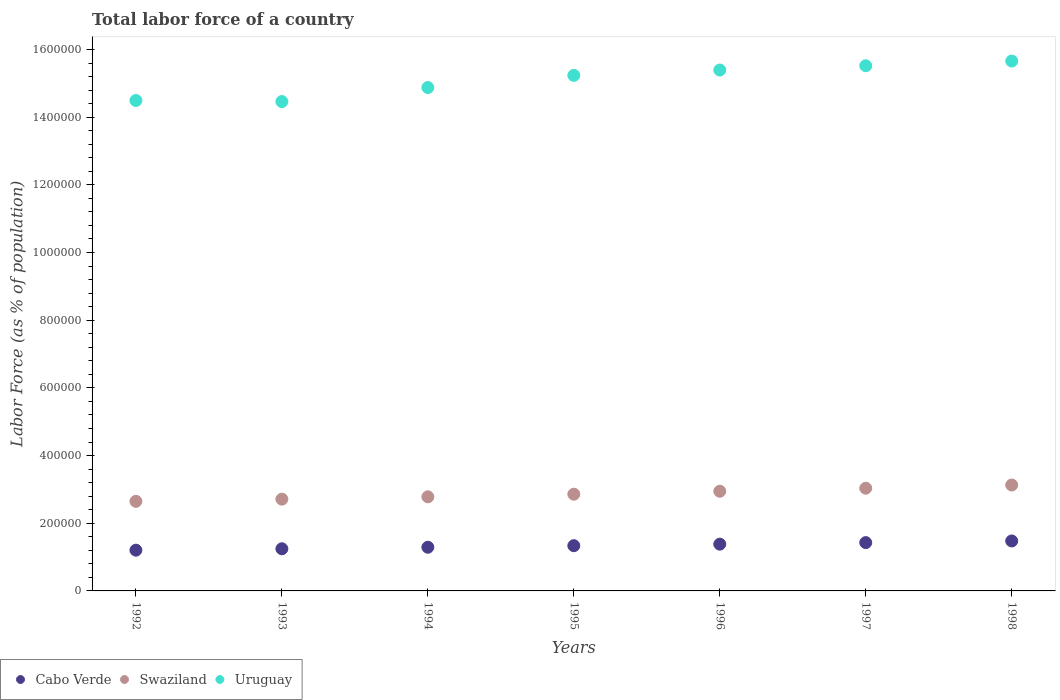How many different coloured dotlines are there?
Your answer should be very brief. 3. Is the number of dotlines equal to the number of legend labels?
Offer a very short reply. Yes. What is the percentage of labor force in Uruguay in 1997?
Ensure brevity in your answer.  1.55e+06. Across all years, what is the maximum percentage of labor force in Swaziland?
Your answer should be very brief. 3.13e+05. Across all years, what is the minimum percentage of labor force in Swaziland?
Provide a succinct answer. 2.65e+05. In which year was the percentage of labor force in Uruguay maximum?
Offer a very short reply. 1998. In which year was the percentage of labor force in Swaziland minimum?
Offer a terse response. 1992. What is the total percentage of labor force in Uruguay in the graph?
Ensure brevity in your answer.  1.06e+07. What is the difference between the percentage of labor force in Uruguay in 1994 and that in 1998?
Make the answer very short. -7.83e+04. What is the difference between the percentage of labor force in Swaziland in 1993 and the percentage of labor force in Cabo Verde in 1996?
Your response must be concise. 1.33e+05. What is the average percentage of labor force in Uruguay per year?
Provide a short and direct response. 1.51e+06. In the year 1993, what is the difference between the percentage of labor force in Cabo Verde and percentage of labor force in Swaziland?
Your response must be concise. -1.47e+05. What is the ratio of the percentage of labor force in Uruguay in 1997 to that in 1998?
Give a very brief answer. 0.99. What is the difference between the highest and the second highest percentage of labor force in Uruguay?
Make the answer very short. 1.39e+04. What is the difference between the highest and the lowest percentage of labor force in Uruguay?
Your answer should be very brief. 1.20e+05. In how many years, is the percentage of labor force in Uruguay greater than the average percentage of labor force in Uruguay taken over all years?
Your answer should be very brief. 4. Is the sum of the percentage of labor force in Cabo Verde in 1992 and 1996 greater than the maximum percentage of labor force in Uruguay across all years?
Your response must be concise. No. Is it the case that in every year, the sum of the percentage of labor force in Cabo Verde and percentage of labor force in Swaziland  is greater than the percentage of labor force in Uruguay?
Offer a terse response. No. How many dotlines are there?
Your answer should be compact. 3. What is the difference between two consecutive major ticks on the Y-axis?
Your answer should be very brief. 2.00e+05. Are the values on the major ticks of Y-axis written in scientific E-notation?
Keep it short and to the point. No. Does the graph contain grids?
Your answer should be compact. No. How many legend labels are there?
Offer a very short reply. 3. What is the title of the graph?
Ensure brevity in your answer.  Total labor force of a country. What is the label or title of the Y-axis?
Your response must be concise. Labor Force (as % of population). What is the Labor Force (as % of population) in Cabo Verde in 1992?
Offer a terse response. 1.20e+05. What is the Labor Force (as % of population) of Swaziland in 1992?
Make the answer very short. 2.65e+05. What is the Labor Force (as % of population) of Uruguay in 1992?
Give a very brief answer. 1.45e+06. What is the Labor Force (as % of population) in Cabo Verde in 1993?
Offer a terse response. 1.25e+05. What is the Labor Force (as % of population) of Swaziland in 1993?
Your answer should be compact. 2.71e+05. What is the Labor Force (as % of population) of Uruguay in 1993?
Provide a succinct answer. 1.45e+06. What is the Labor Force (as % of population) of Cabo Verde in 1994?
Your answer should be very brief. 1.29e+05. What is the Labor Force (as % of population) in Swaziland in 1994?
Keep it short and to the point. 2.78e+05. What is the Labor Force (as % of population) in Uruguay in 1994?
Your response must be concise. 1.49e+06. What is the Labor Force (as % of population) in Cabo Verde in 1995?
Provide a succinct answer. 1.34e+05. What is the Labor Force (as % of population) in Swaziland in 1995?
Make the answer very short. 2.86e+05. What is the Labor Force (as % of population) in Uruguay in 1995?
Make the answer very short. 1.52e+06. What is the Labor Force (as % of population) of Cabo Verde in 1996?
Offer a terse response. 1.38e+05. What is the Labor Force (as % of population) of Swaziland in 1996?
Provide a short and direct response. 2.95e+05. What is the Labor Force (as % of population) in Uruguay in 1996?
Provide a short and direct response. 1.54e+06. What is the Labor Force (as % of population) in Cabo Verde in 1997?
Ensure brevity in your answer.  1.43e+05. What is the Labor Force (as % of population) in Swaziland in 1997?
Provide a succinct answer. 3.04e+05. What is the Labor Force (as % of population) in Uruguay in 1997?
Your answer should be compact. 1.55e+06. What is the Labor Force (as % of population) of Cabo Verde in 1998?
Provide a short and direct response. 1.48e+05. What is the Labor Force (as % of population) of Swaziland in 1998?
Make the answer very short. 3.13e+05. What is the Labor Force (as % of population) of Uruguay in 1998?
Make the answer very short. 1.57e+06. Across all years, what is the maximum Labor Force (as % of population) of Cabo Verde?
Make the answer very short. 1.48e+05. Across all years, what is the maximum Labor Force (as % of population) in Swaziland?
Provide a succinct answer. 3.13e+05. Across all years, what is the maximum Labor Force (as % of population) of Uruguay?
Keep it short and to the point. 1.57e+06. Across all years, what is the minimum Labor Force (as % of population) in Cabo Verde?
Your answer should be very brief. 1.20e+05. Across all years, what is the minimum Labor Force (as % of population) in Swaziland?
Your answer should be compact. 2.65e+05. Across all years, what is the minimum Labor Force (as % of population) in Uruguay?
Your response must be concise. 1.45e+06. What is the total Labor Force (as % of population) of Cabo Verde in the graph?
Your answer should be very brief. 9.36e+05. What is the total Labor Force (as % of population) of Swaziland in the graph?
Provide a succinct answer. 2.01e+06. What is the total Labor Force (as % of population) in Uruguay in the graph?
Make the answer very short. 1.06e+07. What is the difference between the Labor Force (as % of population) in Cabo Verde in 1992 and that in 1993?
Make the answer very short. -4156. What is the difference between the Labor Force (as % of population) of Swaziland in 1992 and that in 1993?
Your response must be concise. -6428. What is the difference between the Labor Force (as % of population) of Uruguay in 1992 and that in 1993?
Provide a succinct answer. 3182. What is the difference between the Labor Force (as % of population) of Cabo Verde in 1992 and that in 1994?
Offer a very short reply. -8673. What is the difference between the Labor Force (as % of population) in Swaziland in 1992 and that in 1994?
Offer a very short reply. -1.33e+04. What is the difference between the Labor Force (as % of population) in Uruguay in 1992 and that in 1994?
Ensure brevity in your answer.  -3.83e+04. What is the difference between the Labor Force (as % of population) of Cabo Verde in 1992 and that in 1995?
Make the answer very short. -1.33e+04. What is the difference between the Labor Force (as % of population) in Swaziland in 1992 and that in 1995?
Offer a very short reply. -2.11e+04. What is the difference between the Labor Force (as % of population) in Uruguay in 1992 and that in 1995?
Your answer should be very brief. -7.42e+04. What is the difference between the Labor Force (as % of population) in Cabo Verde in 1992 and that in 1996?
Provide a succinct answer. -1.78e+04. What is the difference between the Labor Force (as % of population) in Swaziland in 1992 and that in 1996?
Your response must be concise. -2.98e+04. What is the difference between the Labor Force (as % of population) in Uruguay in 1992 and that in 1996?
Offer a very short reply. -9.00e+04. What is the difference between the Labor Force (as % of population) in Cabo Verde in 1992 and that in 1997?
Make the answer very short. -2.23e+04. What is the difference between the Labor Force (as % of population) of Swaziland in 1992 and that in 1997?
Keep it short and to the point. -3.87e+04. What is the difference between the Labor Force (as % of population) in Uruguay in 1992 and that in 1997?
Your response must be concise. -1.03e+05. What is the difference between the Labor Force (as % of population) in Cabo Verde in 1992 and that in 1998?
Your response must be concise. -2.72e+04. What is the difference between the Labor Force (as % of population) in Swaziland in 1992 and that in 1998?
Your response must be concise. -4.81e+04. What is the difference between the Labor Force (as % of population) in Uruguay in 1992 and that in 1998?
Your answer should be compact. -1.17e+05. What is the difference between the Labor Force (as % of population) of Cabo Verde in 1993 and that in 1994?
Offer a very short reply. -4517. What is the difference between the Labor Force (as % of population) of Swaziland in 1993 and that in 1994?
Provide a succinct answer. -6888. What is the difference between the Labor Force (as % of population) in Uruguay in 1993 and that in 1994?
Make the answer very short. -4.15e+04. What is the difference between the Labor Force (as % of population) of Cabo Verde in 1993 and that in 1995?
Provide a short and direct response. -9101. What is the difference between the Labor Force (as % of population) in Swaziland in 1993 and that in 1995?
Your answer should be compact. -1.46e+04. What is the difference between the Labor Force (as % of population) of Uruguay in 1993 and that in 1995?
Your answer should be very brief. -7.74e+04. What is the difference between the Labor Force (as % of population) of Cabo Verde in 1993 and that in 1996?
Ensure brevity in your answer.  -1.37e+04. What is the difference between the Labor Force (as % of population) of Swaziland in 1993 and that in 1996?
Your answer should be very brief. -2.33e+04. What is the difference between the Labor Force (as % of population) in Uruguay in 1993 and that in 1996?
Make the answer very short. -9.32e+04. What is the difference between the Labor Force (as % of population) in Cabo Verde in 1993 and that in 1997?
Keep it short and to the point. -1.82e+04. What is the difference between the Labor Force (as % of population) in Swaziland in 1993 and that in 1997?
Give a very brief answer. -3.23e+04. What is the difference between the Labor Force (as % of population) of Uruguay in 1993 and that in 1997?
Keep it short and to the point. -1.06e+05. What is the difference between the Labor Force (as % of population) in Cabo Verde in 1993 and that in 1998?
Your answer should be very brief. -2.31e+04. What is the difference between the Labor Force (as % of population) of Swaziland in 1993 and that in 1998?
Make the answer very short. -4.17e+04. What is the difference between the Labor Force (as % of population) in Uruguay in 1993 and that in 1998?
Give a very brief answer. -1.20e+05. What is the difference between the Labor Force (as % of population) of Cabo Verde in 1994 and that in 1995?
Provide a succinct answer. -4584. What is the difference between the Labor Force (as % of population) of Swaziland in 1994 and that in 1995?
Offer a very short reply. -7754. What is the difference between the Labor Force (as % of population) in Uruguay in 1994 and that in 1995?
Your answer should be very brief. -3.59e+04. What is the difference between the Labor Force (as % of population) of Cabo Verde in 1994 and that in 1996?
Your answer should be compact. -9141. What is the difference between the Labor Force (as % of population) in Swaziland in 1994 and that in 1996?
Keep it short and to the point. -1.64e+04. What is the difference between the Labor Force (as % of population) in Uruguay in 1994 and that in 1996?
Your response must be concise. -5.17e+04. What is the difference between the Labor Force (as % of population) in Cabo Verde in 1994 and that in 1997?
Your answer should be compact. -1.36e+04. What is the difference between the Labor Force (as % of population) of Swaziland in 1994 and that in 1997?
Keep it short and to the point. -2.54e+04. What is the difference between the Labor Force (as % of population) of Uruguay in 1994 and that in 1997?
Your answer should be compact. -6.44e+04. What is the difference between the Labor Force (as % of population) of Cabo Verde in 1994 and that in 1998?
Ensure brevity in your answer.  -1.86e+04. What is the difference between the Labor Force (as % of population) in Swaziland in 1994 and that in 1998?
Keep it short and to the point. -3.48e+04. What is the difference between the Labor Force (as % of population) of Uruguay in 1994 and that in 1998?
Keep it short and to the point. -7.83e+04. What is the difference between the Labor Force (as % of population) of Cabo Verde in 1995 and that in 1996?
Ensure brevity in your answer.  -4557. What is the difference between the Labor Force (as % of population) of Swaziland in 1995 and that in 1996?
Offer a terse response. -8696. What is the difference between the Labor Force (as % of population) in Uruguay in 1995 and that in 1996?
Give a very brief answer. -1.58e+04. What is the difference between the Labor Force (as % of population) in Cabo Verde in 1995 and that in 1997?
Your answer should be compact. -9062. What is the difference between the Labor Force (as % of population) of Swaziland in 1995 and that in 1997?
Offer a terse response. -1.77e+04. What is the difference between the Labor Force (as % of population) of Uruguay in 1995 and that in 1997?
Keep it short and to the point. -2.85e+04. What is the difference between the Labor Force (as % of population) in Cabo Verde in 1995 and that in 1998?
Provide a succinct answer. -1.40e+04. What is the difference between the Labor Force (as % of population) of Swaziland in 1995 and that in 1998?
Your answer should be compact. -2.71e+04. What is the difference between the Labor Force (as % of population) in Uruguay in 1995 and that in 1998?
Keep it short and to the point. -4.24e+04. What is the difference between the Labor Force (as % of population) of Cabo Verde in 1996 and that in 1997?
Provide a succinct answer. -4505. What is the difference between the Labor Force (as % of population) in Swaziland in 1996 and that in 1997?
Provide a succinct answer. -8958. What is the difference between the Labor Force (as % of population) of Uruguay in 1996 and that in 1997?
Offer a very short reply. -1.27e+04. What is the difference between the Labor Force (as % of population) of Cabo Verde in 1996 and that in 1998?
Your answer should be compact. -9420. What is the difference between the Labor Force (as % of population) in Swaziland in 1996 and that in 1998?
Ensure brevity in your answer.  -1.84e+04. What is the difference between the Labor Force (as % of population) of Uruguay in 1996 and that in 1998?
Your answer should be compact. -2.66e+04. What is the difference between the Labor Force (as % of population) in Cabo Verde in 1997 and that in 1998?
Keep it short and to the point. -4915. What is the difference between the Labor Force (as % of population) in Swaziland in 1997 and that in 1998?
Your answer should be very brief. -9414. What is the difference between the Labor Force (as % of population) in Uruguay in 1997 and that in 1998?
Provide a succinct answer. -1.39e+04. What is the difference between the Labor Force (as % of population) in Cabo Verde in 1992 and the Labor Force (as % of population) in Swaziland in 1993?
Offer a very short reply. -1.51e+05. What is the difference between the Labor Force (as % of population) of Cabo Verde in 1992 and the Labor Force (as % of population) of Uruguay in 1993?
Your answer should be compact. -1.33e+06. What is the difference between the Labor Force (as % of population) in Swaziland in 1992 and the Labor Force (as % of population) in Uruguay in 1993?
Your answer should be compact. -1.18e+06. What is the difference between the Labor Force (as % of population) of Cabo Verde in 1992 and the Labor Force (as % of population) of Swaziland in 1994?
Provide a succinct answer. -1.58e+05. What is the difference between the Labor Force (as % of population) of Cabo Verde in 1992 and the Labor Force (as % of population) of Uruguay in 1994?
Make the answer very short. -1.37e+06. What is the difference between the Labor Force (as % of population) in Swaziland in 1992 and the Labor Force (as % of population) in Uruguay in 1994?
Offer a very short reply. -1.22e+06. What is the difference between the Labor Force (as % of population) in Cabo Verde in 1992 and the Labor Force (as % of population) in Swaziland in 1995?
Keep it short and to the point. -1.65e+05. What is the difference between the Labor Force (as % of population) in Cabo Verde in 1992 and the Labor Force (as % of population) in Uruguay in 1995?
Ensure brevity in your answer.  -1.40e+06. What is the difference between the Labor Force (as % of population) of Swaziland in 1992 and the Labor Force (as % of population) of Uruguay in 1995?
Provide a short and direct response. -1.26e+06. What is the difference between the Labor Force (as % of population) of Cabo Verde in 1992 and the Labor Force (as % of population) of Swaziland in 1996?
Make the answer very short. -1.74e+05. What is the difference between the Labor Force (as % of population) of Cabo Verde in 1992 and the Labor Force (as % of population) of Uruguay in 1996?
Offer a terse response. -1.42e+06. What is the difference between the Labor Force (as % of population) of Swaziland in 1992 and the Labor Force (as % of population) of Uruguay in 1996?
Provide a succinct answer. -1.27e+06. What is the difference between the Labor Force (as % of population) in Cabo Verde in 1992 and the Labor Force (as % of population) in Swaziland in 1997?
Offer a terse response. -1.83e+05. What is the difference between the Labor Force (as % of population) in Cabo Verde in 1992 and the Labor Force (as % of population) in Uruguay in 1997?
Give a very brief answer. -1.43e+06. What is the difference between the Labor Force (as % of population) of Swaziland in 1992 and the Labor Force (as % of population) of Uruguay in 1997?
Provide a short and direct response. -1.29e+06. What is the difference between the Labor Force (as % of population) of Cabo Verde in 1992 and the Labor Force (as % of population) of Swaziland in 1998?
Your answer should be very brief. -1.93e+05. What is the difference between the Labor Force (as % of population) of Cabo Verde in 1992 and the Labor Force (as % of population) of Uruguay in 1998?
Provide a short and direct response. -1.45e+06. What is the difference between the Labor Force (as % of population) of Swaziland in 1992 and the Labor Force (as % of population) of Uruguay in 1998?
Provide a succinct answer. -1.30e+06. What is the difference between the Labor Force (as % of population) of Cabo Verde in 1993 and the Labor Force (as % of population) of Swaziland in 1994?
Offer a very short reply. -1.54e+05. What is the difference between the Labor Force (as % of population) in Cabo Verde in 1993 and the Labor Force (as % of population) in Uruguay in 1994?
Make the answer very short. -1.36e+06. What is the difference between the Labor Force (as % of population) in Swaziland in 1993 and the Labor Force (as % of population) in Uruguay in 1994?
Offer a very short reply. -1.22e+06. What is the difference between the Labor Force (as % of population) of Cabo Verde in 1993 and the Labor Force (as % of population) of Swaziland in 1995?
Your response must be concise. -1.61e+05. What is the difference between the Labor Force (as % of population) in Cabo Verde in 1993 and the Labor Force (as % of population) in Uruguay in 1995?
Your response must be concise. -1.40e+06. What is the difference between the Labor Force (as % of population) of Swaziland in 1993 and the Labor Force (as % of population) of Uruguay in 1995?
Ensure brevity in your answer.  -1.25e+06. What is the difference between the Labor Force (as % of population) in Cabo Verde in 1993 and the Labor Force (as % of population) in Swaziland in 1996?
Provide a short and direct response. -1.70e+05. What is the difference between the Labor Force (as % of population) of Cabo Verde in 1993 and the Labor Force (as % of population) of Uruguay in 1996?
Your response must be concise. -1.41e+06. What is the difference between the Labor Force (as % of population) of Swaziland in 1993 and the Labor Force (as % of population) of Uruguay in 1996?
Your answer should be very brief. -1.27e+06. What is the difference between the Labor Force (as % of population) of Cabo Verde in 1993 and the Labor Force (as % of population) of Swaziland in 1997?
Offer a terse response. -1.79e+05. What is the difference between the Labor Force (as % of population) in Cabo Verde in 1993 and the Labor Force (as % of population) in Uruguay in 1997?
Give a very brief answer. -1.43e+06. What is the difference between the Labor Force (as % of population) in Swaziland in 1993 and the Labor Force (as % of population) in Uruguay in 1997?
Your response must be concise. -1.28e+06. What is the difference between the Labor Force (as % of population) in Cabo Verde in 1993 and the Labor Force (as % of population) in Swaziland in 1998?
Keep it short and to the point. -1.88e+05. What is the difference between the Labor Force (as % of population) in Cabo Verde in 1993 and the Labor Force (as % of population) in Uruguay in 1998?
Ensure brevity in your answer.  -1.44e+06. What is the difference between the Labor Force (as % of population) of Swaziland in 1993 and the Labor Force (as % of population) of Uruguay in 1998?
Provide a short and direct response. -1.29e+06. What is the difference between the Labor Force (as % of population) of Cabo Verde in 1994 and the Labor Force (as % of population) of Swaziland in 1995?
Your answer should be compact. -1.57e+05. What is the difference between the Labor Force (as % of population) in Cabo Verde in 1994 and the Labor Force (as % of population) in Uruguay in 1995?
Offer a terse response. -1.39e+06. What is the difference between the Labor Force (as % of population) of Swaziland in 1994 and the Labor Force (as % of population) of Uruguay in 1995?
Make the answer very short. -1.25e+06. What is the difference between the Labor Force (as % of population) in Cabo Verde in 1994 and the Labor Force (as % of population) in Swaziland in 1996?
Offer a very short reply. -1.65e+05. What is the difference between the Labor Force (as % of population) of Cabo Verde in 1994 and the Labor Force (as % of population) of Uruguay in 1996?
Give a very brief answer. -1.41e+06. What is the difference between the Labor Force (as % of population) in Swaziland in 1994 and the Labor Force (as % of population) in Uruguay in 1996?
Give a very brief answer. -1.26e+06. What is the difference between the Labor Force (as % of population) in Cabo Verde in 1994 and the Labor Force (as % of population) in Swaziland in 1997?
Offer a terse response. -1.74e+05. What is the difference between the Labor Force (as % of population) of Cabo Verde in 1994 and the Labor Force (as % of population) of Uruguay in 1997?
Make the answer very short. -1.42e+06. What is the difference between the Labor Force (as % of population) in Swaziland in 1994 and the Labor Force (as % of population) in Uruguay in 1997?
Offer a very short reply. -1.27e+06. What is the difference between the Labor Force (as % of population) in Cabo Verde in 1994 and the Labor Force (as % of population) in Swaziland in 1998?
Offer a very short reply. -1.84e+05. What is the difference between the Labor Force (as % of population) of Cabo Verde in 1994 and the Labor Force (as % of population) of Uruguay in 1998?
Ensure brevity in your answer.  -1.44e+06. What is the difference between the Labor Force (as % of population) of Swaziland in 1994 and the Labor Force (as % of population) of Uruguay in 1998?
Provide a succinct answer. -1.29e+06. What is the difference between the Labor Force (as % of population) of Cabo Verde in 1995 and the Labor Force (as % of population) of Swaziland in 1996?
Ensure brevity in your answer.  -1.61e+05. What is the difference between the Labor Force (as % of population) in Cabo Verde in 1995 and the Labor Force (as % of population) in Uruguay in 1996?
Your answer should be compact. -1.41e+06. What is the difference between the Labor Force (as % of population) in Swaziland in 1995 and the Labor Force (as % of population) in Uruguay in 1996?
Give a very brief answer. -1.25e+06. What is the difference between the Labor Force (as % of population) in Cabo Verde in 1995 and the Labor Force (as % of population) in Swaziland in 1997?
Offer a terse response. -1.70e+05. What is the difference between the Labor Force (as % of population) of Cabo Verde in 1995 and the Labor Force (as % of population) of Uruguay in 1997?
Provide a succinct answer. -1.42e+06. What is the difference between the Labor Force (as % of population) of Swaziland in 1995 and the Labor Force (as % of population) of Uruguay in 1997?
Give a very brief answer. -1.27e+06. What is the difference between the Labor Force (as % of population) of Cabo Verde in 1995 and the Labor Force (as % of population) of Swaziland in 1998?
Ensure brevity in your answer.  -1.79e+05. What is the difference between the Labor Force (as % of population) in Cabo Verde in 1995 and the Labor Force (as % of population) in Uruguay in 1998?
Provide a short and direct response. -1.43e+06. What is the difference between the Labor Force (as % of population) in Swaziland in 1995 and the Labor Force (as % of population) in Uruguay in 1998?
Offer a very short reply. -1.28e+06. What is the difference between the Labor Force (as % of population) of Cabo Verde in 1996 and the Labor Force (as % of population) of Swaziland in 1997?
Offer a terse response. -1.65e+05. What is the difference between the Labor Force (as % of population) of Cabo Verde in 1996 and the Labor Force (as % of population) of Uruguay in 1997?
Ensure brevity in your answer.  -1.41e+06. What is the difference between the Labor Force (as % of population) of Swaziland in 1996 and the Labor Force (as % of population) of Uruguay in 1997?
Your answer should be very brief. -1.26e+06. What is the difference between the Labor Force (as % of population) of Cabo Verde in 1996 and the Labor Force (as % of population) of Swaziland in 1998?
Your answer should be compact. -1.75e+05. What is the difference between the Labor Force (as % of population) of Cabo Verde in 1996 and the Labor Force (as % of population) of Uruguay in 1998?
Keep it short and to the point. -1.43e+06. What is the difference between the Labor Force (as % of population) of Swaziland in 1996 and the Labor Force (as % of population) of Uruguay in 1998?
Provide a short and direct response. -1.27e+06. What is the difference between the Labor Force (as % of population) in Cabo Verde in 1997 and the Labor Force (as % of population) in Swaziland in 1998?
Give a very brief answer. -1.70e+05. What is the difference between the Labor Force (as % of population) in Cabo Verde in 1997 and the Labor Force (as % of population) in Uruguay in 1998?
Your answer should be very brief. -1.42e+06. What is the difference between the Labor Force (as % of population) of Swaziland in 1997 and the Labor Force (as % of population) of Uruguay in 1998?
Provide a succinct answer. -1.26e+06. What is the average Labor Force (as % of population) in Cabo Verde per year?
Offer a very short reply. 1.34e+05. What is the average Labor Force (as % of population) of Swaziland per year?
Offer a very short reply. 2.87e+05. What is the average Labor Force (as % of population) in Uruguay per year?
Your response must be concise. 1.51e+06. In the year 1992, what is the difference between the Labor Force (as % of population) of Cabo Verde and Labor Force (as % of population) of Swaziland?
Make the answer very short. -1.44e+05. In the year 1992, what is the difference between the Labor Force (as % of population) in Cabo Verde and Labor Force (as % of population) in Uruguay?
Make the answer very short. -1.33e+06. In the year 1992, what is the difference between the Labor Force (as % of population) of Swaziland and Labor Force (as % of population) of Uruguay?
Make the answer very short. -1.18e+06. In the year 1993, what is the difference between the Labor Force (as % of population) of Cabo Verde and Labor Force (as % of population) of Swaziland?
Offer a very short reply. -1.47e+05. In the year 1993, what is the difference between the Labor Force (as % of population) in Cabo Verde and Labor Force (as % of population) in Uruguay?
Keep it short and to the point. -1.32e+06. In the year 1993, what is the difference between the Labor Force (as % of population) of Swaziland and Labor Force (as % of population) of Uruguay?
Give a very brief answer. -1.17e+06. In the year 1994, what is the difference between the Labor Force (as % of population) of Cabo Verde and Labor Force (as % of population) of Swaziland?
Make the answer very short. -1.49e+05. In the year 1994, what is the difference between the Labor Force (as % of population) in Cabo Verde and Labor Force (as % of population) in Uruguay?
Your answer should be very brief. -1.36e+06. In the year 1994, what is the difference between the Labor Force (as % of population) of Swaziland and Labor Force (as % of population) of Uruguay?
Your answer should be very brief. -1.21e+06. In the year 1995, what is the difference between the Labor Force (as % of population) in Cabo Verde and Labor Force (as % of population) in Swaziland?
Keep it short and to the point. -1.52e+05. In the year 1995, what is the difference between the Labor Force (as % of population) of Cabo Verde and Labor Force (as % of population) of Uruguay?
Keep it short and to the point. -1.39e+06. In the year 1995, what is the difference between the Labor Force (as % of population) of Swaziland and Labor Force (as % of population) of Uruguay?
Provide a succinct answer. -1.24e+06. In the year 1996, what is the difference between the Labor Force (as % of population) of Cabo Verde and Labor Force (as % of population) of Swaziland?
Your answer should be compact. -1.56e+05. In the year 1996, what is the difference between the Labor Force (as % of population) in Cabo Verde and Labor Force (as % of population) in Uruguay?
Your response must be concise. -1.40e+06. In the year 1996, what is the difference between the Labor Force (as % of population) in Swaziland and Labor Force (as % of population) in Uruguay?
Provide a succinct answer. -1.24e+06. In the year 1997, what is the difference between the Labor Force (as % of population) in Cabo Verde and Labor Force (as % of population) in Swaziland?
Keep it short and to the point. -1.61e+05. In the year 1997, what is the difference between the Labor Force (as % of population) of Cabo Verde and Labor Force (as % of population) of Uruguay?
Make the answer very short. -1.41e+06. In the year 1997, what is the difference between the Labor Force (as % of population) in Swaziland and Labor Force (as % of population) in Uruguay?
Make the answer very short. -1.25e+06. In the year 1998, what is the difference between the Labor Force (as % of population) of Cabo Verde and Labor Force (as % of population) of Swaziland?
Make the answer very short. -1.65e+05. In the year 1998, what is the difference between the Labor Force (as % of population) in Cabo Verde and Labor Force (as % of population) in Uruguay?
Ensure brevity in your answer.  -1.42e+06. In the year 1998, what is the difference between the Labor Force (as % of population) of Swaziland and Labor Force (as % of population) of Uruguay?
Your response must be concise. -1.25e+06. What is the ratio of the Labor Force (as % of population) of Cabo Verde in 1992 to that in 1993?
Offer a very short reply. 0.97. What is the ratio of the Labor Force (as % of population) of Swaziland in 1992 to that in 1993?
Give a very brief answer. 0.98. What is the ratio of the Labor Force (as % of population) of Cabo Verde in 1992 to that in 1994?
Provide a short and direct response. 0.93. What is the ratio of the Labor Force (as % of population) in Swaziland in 1992 to that in 1994?
Make the answer very short. 0.95. What is the ratio of the Labor Force (as % of population) of Uruguay in 1992 to that in 1994?
Provide a short and direct response. 0.97. What is the ratio of the Labor Force (as % of population) of Cabo Verde in 1992 to that in 1995?
Give a very brief answer. 0.9. What is the ratio of the Labor Force (as % of population) of Swaziland in 1992 to that in 1995?
Provide a succinct answer. 0.93. What is the ratio of the Labor Force (as % of population) of Uruguay in 1992 to that in 1995?
Offer a very short reply. 0.95. What is the ratio of the Labor Force (as % of population) of Cabo Verde in 1992 to that in 1996?
Provide a succinct answer. 0.87. What is the ratio of the Labor Force (as % of population) of Swaziland in 1992 to that in 1996?
Give a very brief answer. 0.9. What is the ratio of the Labor Force (as % of population) in Uruguay in 1992 to that in 1996?
Provide a succinct answer. 0.94. What is the ratio of the Labor Force (as % of population) in Cabo Verde in 1992 to that in 1997?
Provide a short and direct response. 0.84. What is the ratio of the Labor Force (as % of population) of Swaziland in 1992 to that in 1997?
Give a very brief answer. 0.87. What is the ratio of the Labor Force (as % of population) in Uruguay in 1992 to that in 1997?
Your answer should be very brief. 0.93. What is the ratio of the Labor Force (as % of population) in Cabo Verde in 1992 to that in 1998?
Make the answer very short. 0.82. What is the ratio of the Labor Force (as % of population) in Swaziland in 1992 to that in 1998?
Provide a short and direct response. 0.85. What is the ratio of the Labor Force (as % of population) of Uruguay in 1992 to that in 1998?
Make the answer very short. 0.93. What is the ratio of the Labor Force (as % of population) of Cabo Verde in 1993 to that in 1994?
Offer a very short reply. 0.96. What is the ratio of the Labor Force (as % of population) in Swaziland in 1993 to that in 1994?
Offer a very short reply. 0.98. What is the ratio of the Labor Force (as % of population) in Uruguay in 1993 to that in 1994?
Offer a very short reply. 0.97. What is the ratio of the Labor Force (as % of population) in Cabo Verde in 1993 to that in 1995?
Provide a succinct answer. 0.93. What is the ratio of the Labor Force (as % of population) in Swaziland in 1993 to that in 1995?
Give a very brief answer. 0.95. What is the ratio of the Labor Force (as % of population) in Uruguay in 1993 to that in 1995?
Offer a very short reply. 0.95. What is the ratio of the Labor Force (as % of population) in Cabo Verde in 1993 to that in 1996?
Keep it short and to the point. 0.9. What is the ratio of the Labor Force (as % of population) in Swaziland in 1993 to that in 1996?
Offer a very short reply. 0.92. What is the ratio of the Labor Force (as % of population) in Uruguay in 1993 to that in 1996?
Your response must be concise. 0.94. What is the ratio of the Labor Force (as % of population) in Cabo Verde in 1993 to that in 1997?
Your answer should be compact. 0.87. What is the ratio of the Labor Force (as % of population) in Swaziland in 1993 to that in 1997?
Your answer should be compact. 0.89. What is the ratio of the Labor Force (as % of population) in Uruguay in 1993 to that in 1997?
Your response must be concise. 0.93. What is the ratio of the Labor Force (as % of population) of Cabo Verde in 1993 to that in 1998?
Provide a succinct answer. 0.84. What is the ratio of the Labor Force (as % of population) in Swaziland in 1993 to that in 1998?
Offer a very short reply. 0.87. What is the ratio of the Labor Force (as % of population) of Uruguay in 1993 to that in 1998?
Keep it short and to the point. 0.92. What is the ratio of the Labor Force (as % of population) of Cabo Verde in 1994 to that in 1995?
Give a very brief answer. 0.97. What is the ratio of the Labor Force (as % of population) of Swaziland in 1994 to that in 1995?
Your answer should be very brief. 0.97. What is the ratio of the Labor Force (as % of population) in Uruguay in 1994 to that in 1995?
Keep it short and to the point. 0.98. What is the ratio of the Labor Force (as % of population) of Cabo Verde in 1994 to that in 1996?
Keep it short and to the point. 0.93. What is the ratio of the Labor Force (as % of population) of Swaziland in 1994 to that in 1996?
Provide a short and direct response. 0.94. What is the ratio of the Labor Force (as % of population) in Uruguay in 1994 to that in 1996?
Provide a succinct answer. 0.97. What is the ratio of the Labor Force (as % of population) of Cabo Verde in 1994 to that in 1997?
Your response must be concise. 0.9. What is the ratio of the Labor Force (as % of population) in Swaziland in 1994 to that in 1997?
Offer a very short reply. 0.92. What is the ratio of the Labor Force (as % of population) of Uruguay in 1994 to that in 1997?
Give a very brief answer. 0.96. What is the ratio of the Labor Force (as % of population) of Cabo Verde in 1994 to that in 1998?
Your response must be concise. 0.87. What is the ratio of the Labor Force (as % of population) in Swaziland in 1994 to that in 1998?
Make the answer very short. 0.89. What is the ratio of the Labor Force (as % of population) of Swaziland in 1995 to that in 1996?
Provide a short and direct response. 0.97. What is the ratio of the Labor Force (as % of population) of Cabo Verde in 1995 to that in 1997?
Provide a succinct answer. 0.94. What is the ratio of the Labor Force (as % of population) of Swaziland in 1995 to that in 1997?
Provide a short and direct response. 0.94. What is the ratio of the Labor Force (as % of population) of Uruguay in 1995 to that in 1997?
Offer a terse response. 0.98. What is the ratio of the Labor Force (as % of population) of Cabo Verde in 1995 to that in 1998?
Make the answer very short. 0.91. What is the ratio of the Labor Force (as % of population) in Swaziland in 1995 to that in 1998?
Your answer should be compact. 0.91. What is the ratio of the Labor Force (as % of population) of Uruguay in 1995 to that in 1998?
Offer a terse response. 0.97. What is the ratio of the Labor Force (as % of population) of Cabo Verde in 1996 to that in 1997?
Keep it short and to the point. 0.97. What is the ratio of the Labor Force (as % of population) of Swaziland in 1996 to that in 1997?
Provide a short and direct response. 0.97. What is the ratio of the Labor Force (as % of population) in Cabo Verde in 1996 to that in 1998?
Keep it short and to the point. 0.94. What is the ratio of the Labor Force (as % of population) in Swaziland in 1996 to that in 1998?
Keep it short and to the point. 0.94. What is the ratio of the Labor Force (as % of population) of Uruguay in 1996 to that in 1998?
Offer a very short reply. 0.98. What is the ratio of the Labor Force (as % of population) in Cabo Verde in 1997 to that in 1998?
Provide a short and direct response. 0.97. What is the ratio of the Labor Force (as % of population) of Swaziland in 1997 to that in 1998?
Give a very brief answer. 0.97. What is the difference between the highest and the second highest Labor Force (as % of population) in Cabo Verde?
Provide a short and direct response. 4915. What is the difference between the highest and the second highest Labor Force (as % of population) in Swaziland?
Provide a succinct answer. 9414. What is the difference between the highest and the second highest Labor Force (as % of population) of Uruguay?
Offer a terse response. 1.39e+04. What is the difference between the highest and the lowest Labor Force (as % of population) of Cabo Verde?
Your answer should be very brief. 2.72e+04. What is the difference between the highest and the lowest Labor Force (as % of population) of Swaziland?
Keep it short and to the point. 4.81e+04. What is the difference between the highest and the lowest Labor Force (as % of population) of Uruguay?
Make the answer very short. 1.20e+05. 